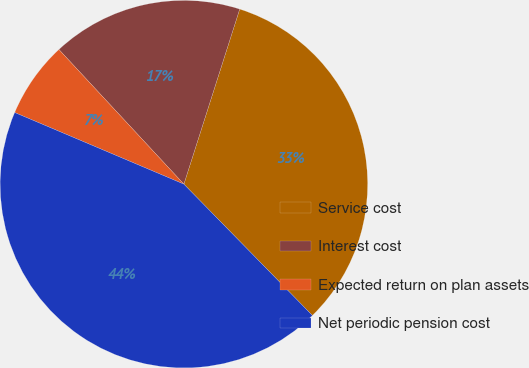Convert chart. <chart><loc_0><loc_0><loc_500><loc_500><pie_chart><fcel>Service cost<fcel>Interest cost<fcel>Expected return on plan assets<fcel>Net periodic pension cost<nl><fcel>32.76%<fcel>16.82%<fcel>6.72%<fcel>43.7%<nl></chart> 